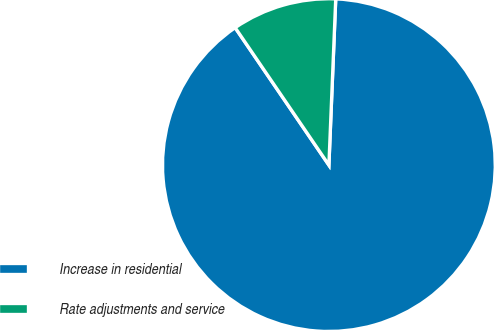Convert chart to OTSL. <chart><loc_0><loc_0><loc_500><loc_500><pie_chart><fcel>Increase in residential<fcel>Rate adjustments and service<nl><fcel>89.82%<fcel>10.18%<nl></chart> 